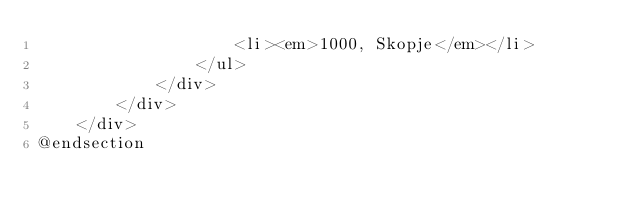Convert code to text. <code><loc_0><loc_0><loc_500><loc_500><_PHP_>                    <li><em>1000, Skopje</em></li>
                </ul>
            </div>
        </div>
    </div>
@endsection
</code> 